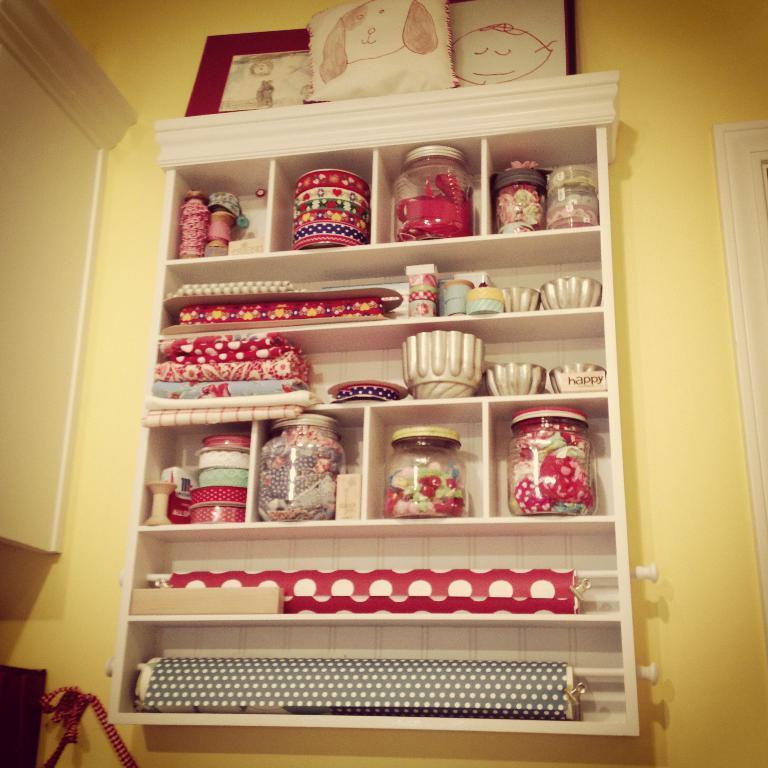Please provide a concise description of this image. In this image I can see a white colored rack in which I can see few glass containers, few bowls and few other objects which are red and black in color. On the rack I can see few photo frames. In the background I can see the yellow colored wall. 